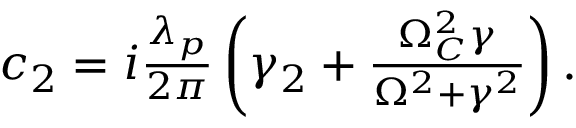Convert formula to latex. <formula><loc_0><loc_0><loc_500><loc_500>\begin{array} { r } { c _ { 2 } = i \frac { \lambda _ { p } } { 2 \pi } \left ( \gamma _ { 2 } + \frac { \Omega _ { C } ^ { 2 } \gamma } { \Omega ^ { 2 } + \gamma ^ { 2 } } \right ) . } \end{array}</formula> 